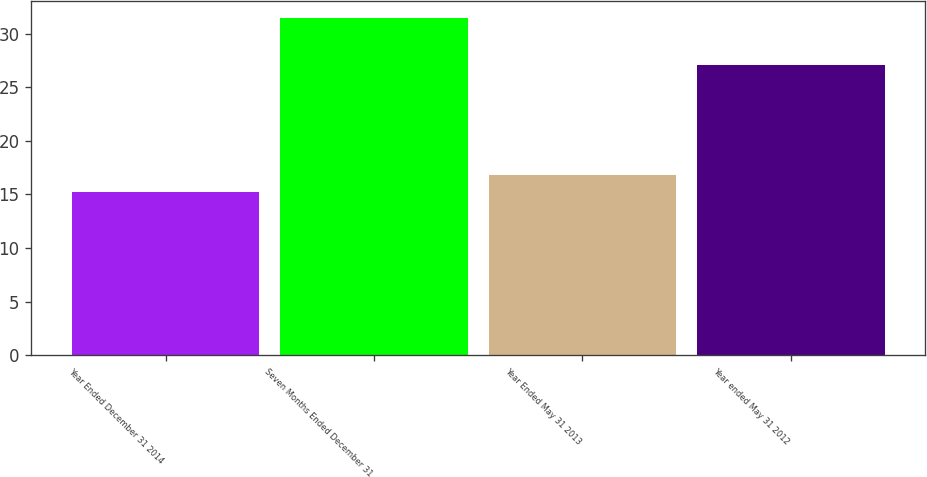<chart> <loc_0><loc_0><loc_500><loc_500><bar_chart><fcel>Year Ended December 31 2014<fcel>Seven Months Ended December 31<fcel>Year Ended May 31 2013<fcel>Year ended May 31 2012<nl><fcel>15.2<fcel>31.5<fcel>16.83<fcel>27.1<nl></chart> 